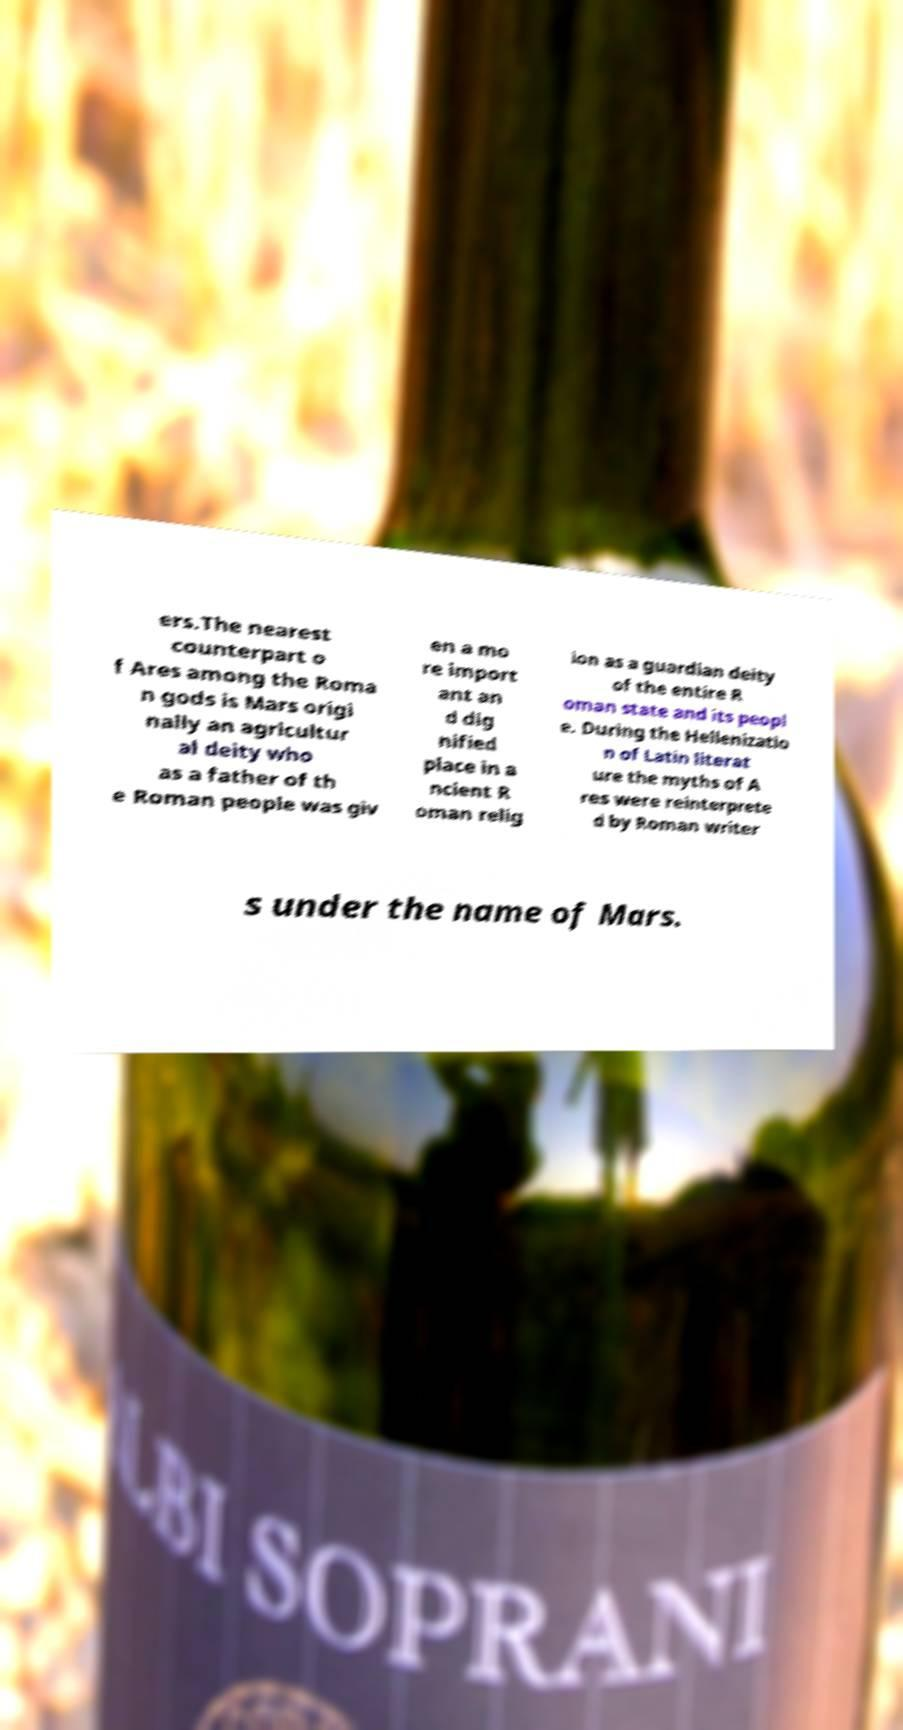Could you assist in decoding the text presented in this image and type it out clearly? ers.The nearest counterpart o f Ares among the Roma n gods is Mars origi nally an agricultur al deity who as a father of th e Roman people was giv en a mo re import ant an d dig nified place in a ncient R oman relig ion as a guardian deity of the entire R oman state and its peopl e. During the Hellenizatio n of Latin literat ure the myths of A res were reinterprete d by Roman writer s under the name of Mars. 